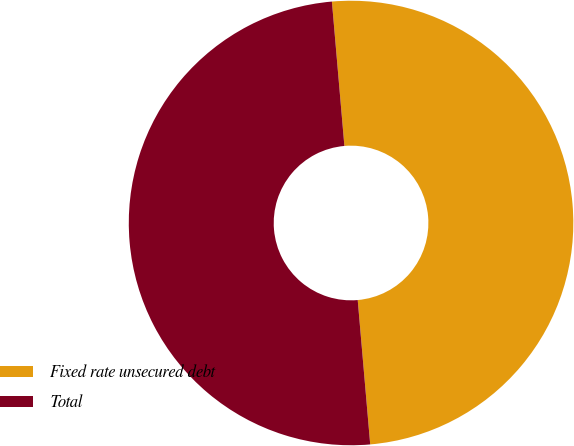<chart> <loc_0><loc_0><loc_500><loc_500><pie_chart><fcel>Fixed rate unsecured debt<fcel>Total<nl><fcel>50.0%<fcel>50.0%<nl></chart> 